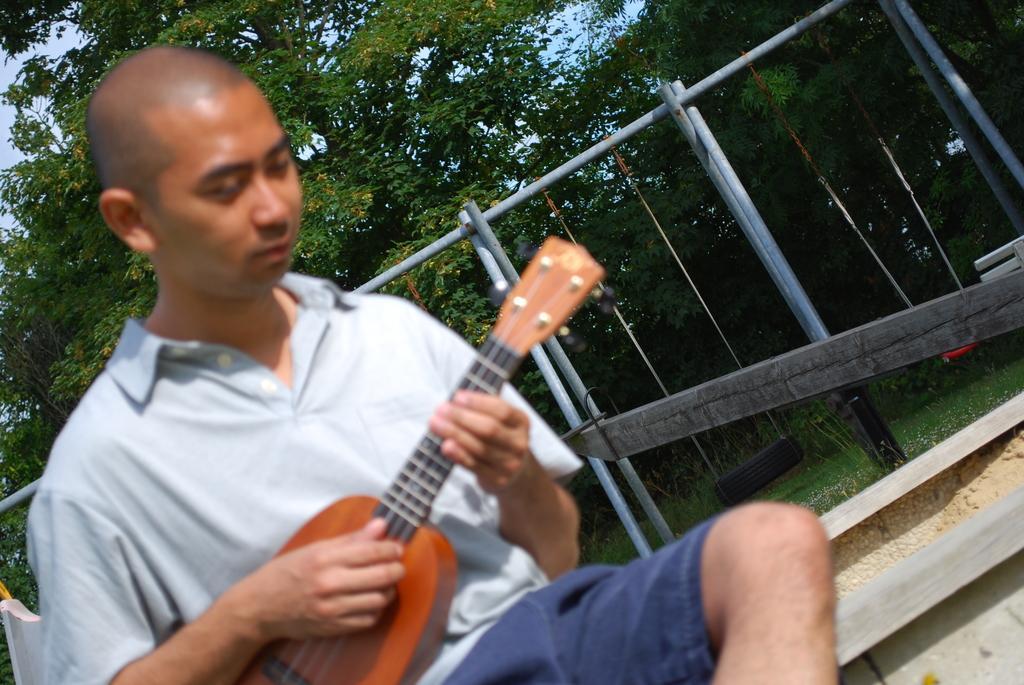Describe this image in one or two sentences. In this image, there is an outside view. In the foreground, there is a person wearing clothes and playing a musical instruments. In the background, there is a fencing and some trees. 